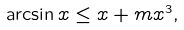Convert formula to latex. <formula><loc_0><loc_0><loc_500><loc_500>\arcsin x \leq x + m x ^ { 3 } ,</formula> 